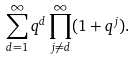Convert formula to latex. <formula><loc_0><loc_0><loc_500><loc_500>\sum _ { d = 1 } ^ { \infty } q ^ { d } \prod _ { j \neq d } ^ { \infty } ( 1 + q ^ { j } ) .</formula> 